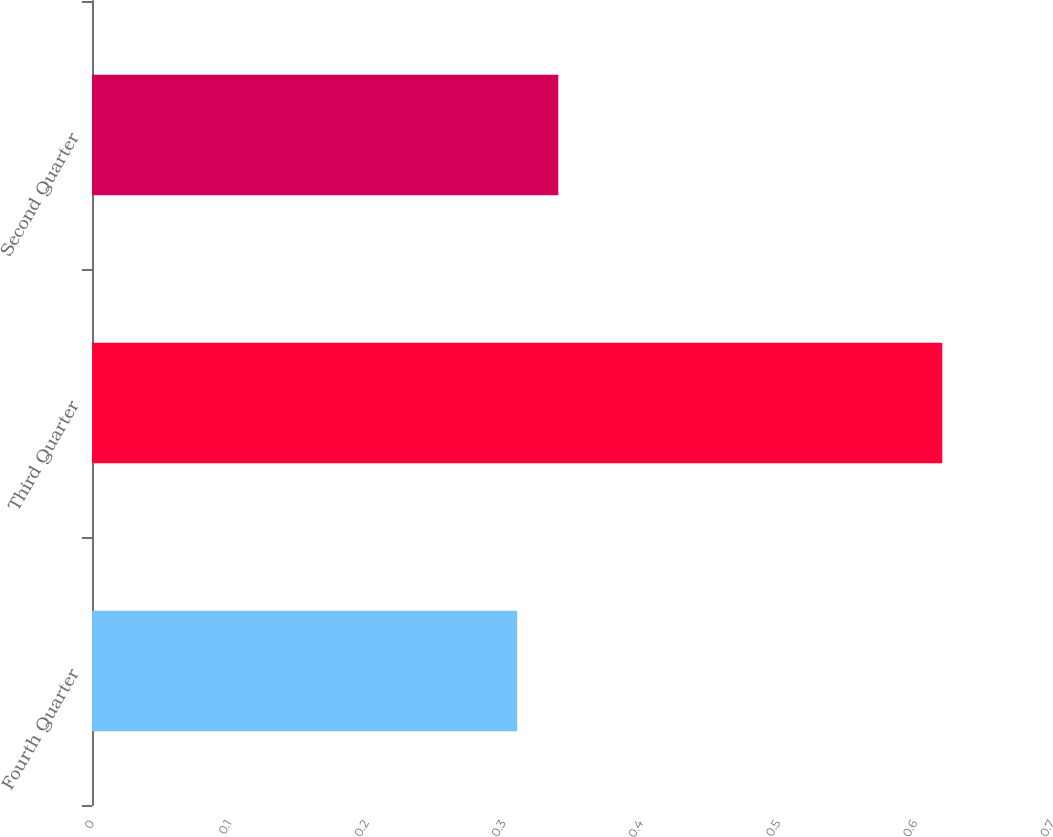Convert chart to OTSL. <chart><loc_0><loc_0><loc_500><loc_500><bar_chart><fcel>Fourth Quarter<fcel>Third Quarter<fcel>Second Quarter<nl><fcel>0.31<fcel>0.62<fcel>0.34<nl></chart> 